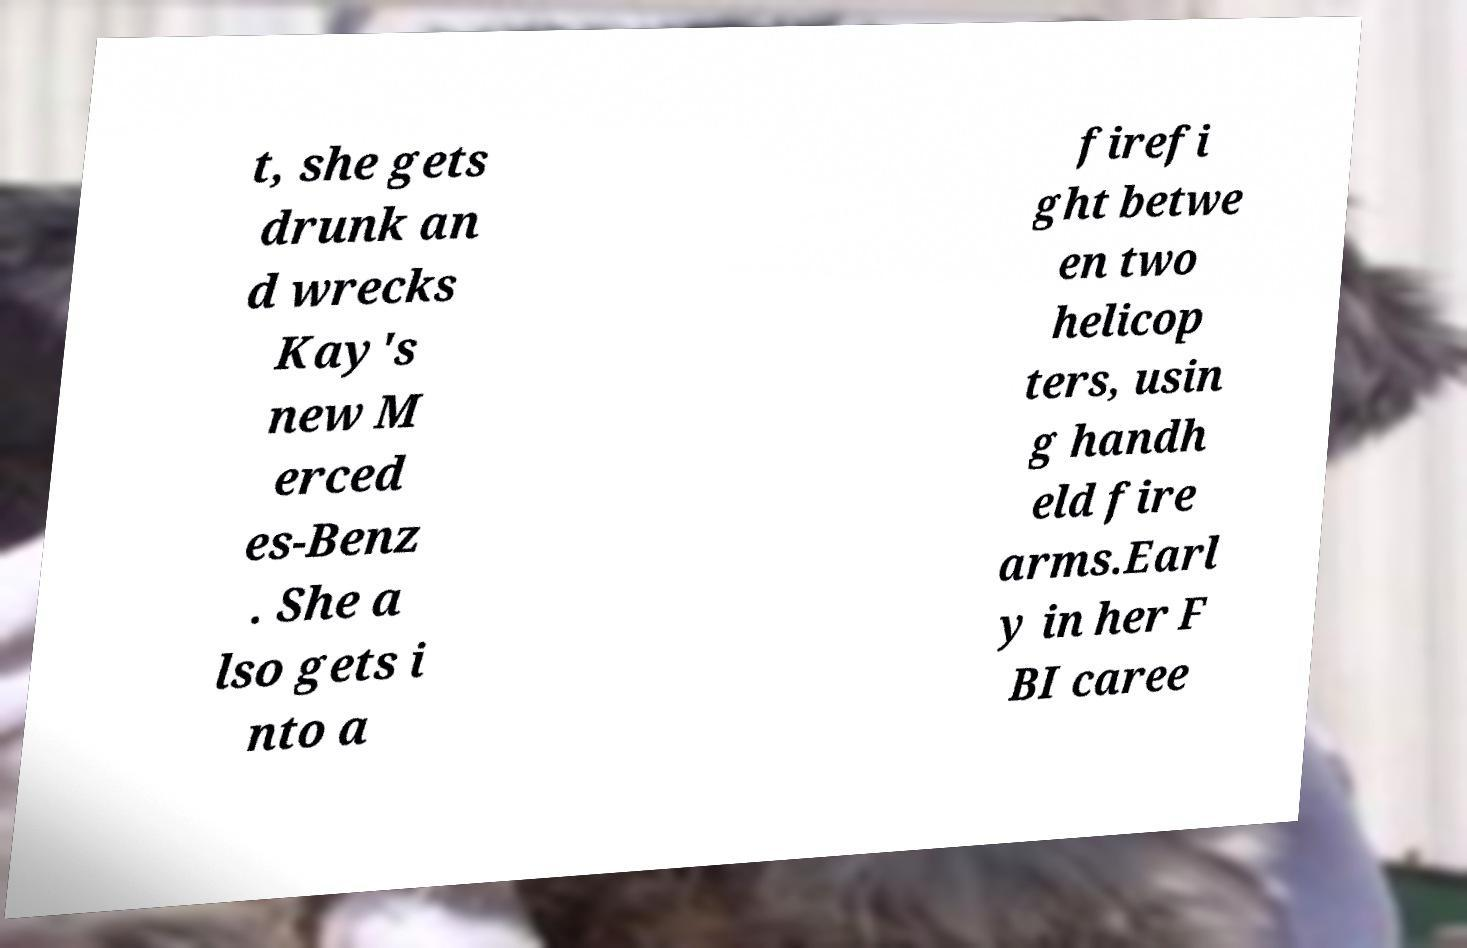Can you read and provide the text displayed in the image?This photo seems to have some interesting text. Can you extract and type it out for me? t, she gets drunk an d wrecks Kay's new M erced es-Benz . She a lso gets i nto a firefi ght betwe en two helicop ters, usin g handh eld fire arms.Earl y in her F BI caree 